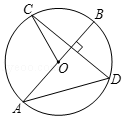How might the lengths of CD and DA be related in this diagram, assuming circle O has a radius of 5 units? Given the circle’s radius of 5 units, and considering point D as the midpoint of chord CD since AB bisects it due to perpendicularity, triangle AOD can be examined using Pythagoras' theorem in right triangles. With OD being 5 units, depending on the length of AD, CD can then be calculated using the properties of the right triangle, demonstrating the interconnected nature of circle geometry. 